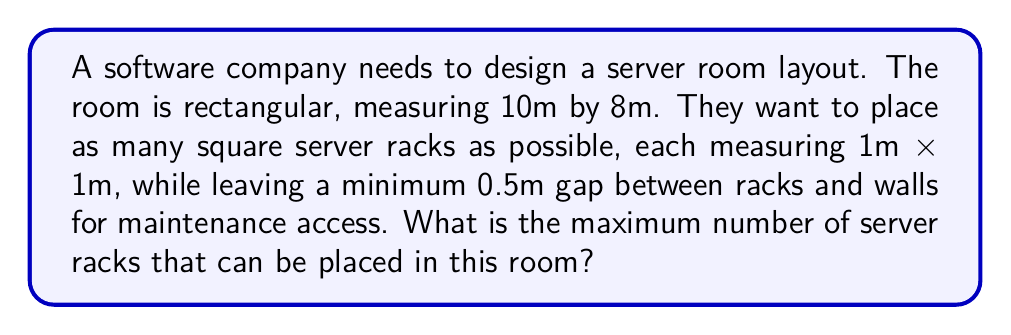Solve this math problem. Let's approach this step-by-step:

1) First, we need to calculate the usable area after accounting for the 0.5m gap around the edges:
   - Length: $10m - (2 \times 0.5m) = 9m$
   - Width: $8m - (2 \times 0.5m) = 7m$

2) Now we have a usable area of 9m x 7m.

3) Since each rack is 1m x 1m, and we need a 0.5m gap between racks, each rack effectively occupies a 1.5m x 1.5m space.

4) To determine how many racks can fit along the length:
   $$ \text{Racks along length} = \lfloor \frac{9m}{1.5m} \rfloor = \lfloor 6 \rfloor = 6 $$

5) To determine how many racks can fit along the width:
   $$ \text{Racks along width} = \lfloor \frac{7m}{1.5m} \rfloor = \lfloor 4.67 \rfloor = 4 $$

6) The total number of racks is the product of these two values:
   $$ \text{Total racks} = 6 \times 4 = 24 $$

[asy]
unitsize(10mm);
draw((0,0)--(10,0)--(10,8)--(0,8)--cycle);
for(int i=0; i<6; ++i) {
  for(int j=0; j<4; ++j) {
    filldraw((1+1.5*i,1+1.5*j)--(2+1.5*i,1+1.5*j)--(2+1.5*i,2+1.5*j)--(1+1.5*i,2+1.5*j)--cycle, gray, black);
  }
}
label("10m", (5,-0.5));
label("8m", (10.5,4));
[/asy]

This diagram illustrates the optimal placement of the server racks within the room.
Answer: 24 server racks 